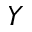Convert formula to latex. <formula><loc_0><loc_0><loc_500><loc_500>Y</formula> 